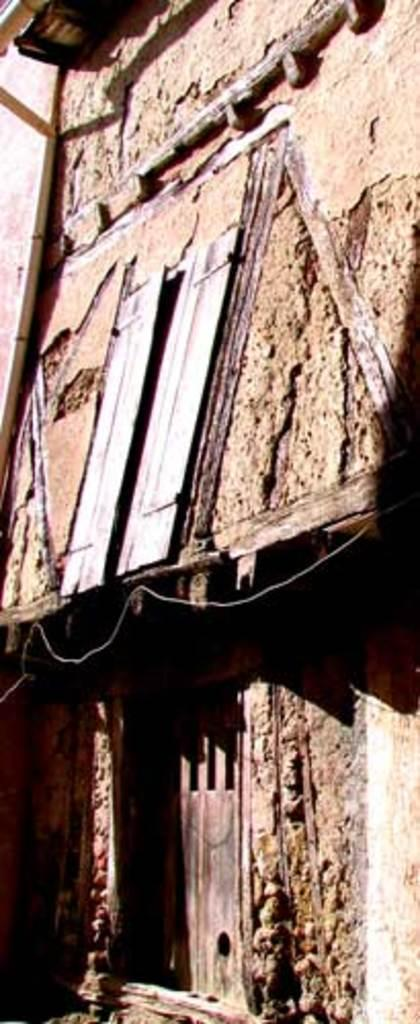What type of structure is present in the image? There is a house in the image. What features can be seen on the house? The house has a window and a door. What is the judge's relation to the number of windows on the house in the image? There is no judge or number of windows mentioned in the image; it only states that the house has a window. 